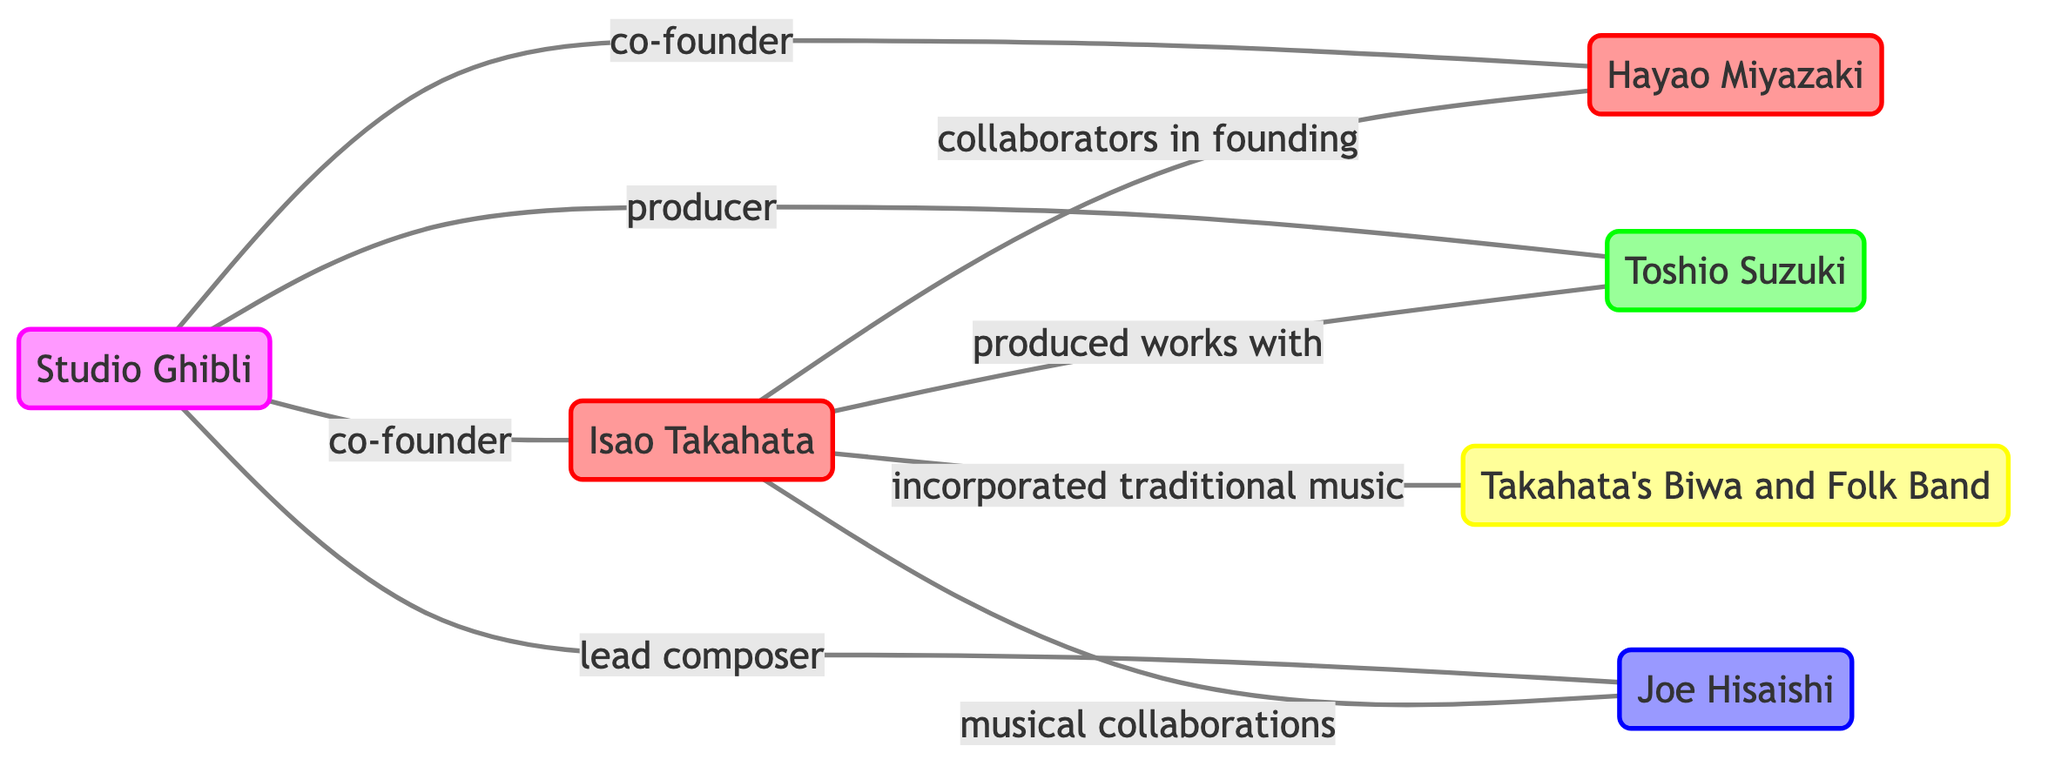What is the total number of nodes in the diagram? The diagram shows six distinct nodes: Isao Takahata, Hayao Miyazaki, Toshio Suzuki, Joe Hisaishi, Takahata's Biwa and Folk Band, and Studio Ghibli. Therefore, the total number is six.
Answer: 6 Who collaborated with Isao Takahata in founding Studio Ghibli? The diagram indicates that Hayao Miyazaki is specifically noted as a collaborator with Isao Takahata in founding Studio Ghibli.
Answer: Hayao Miyazaki What type of role does Toshio Suzuki fulfill in relation to Isao Takahata? Referring to the diagram, Isao Takahata has a relationship labeled 'produced works with' linking him to Toshio Suzuki. This indicates Suzuki's role as a producer for Takahata's works.
Answer: producer How many musical collaborations are indicated for Isao Takahata? The diagram shows that Isao Takahata has a direct link labeled 'musical collaborations' to Joe Hisaishi and another link to 'Takahata's Biwa and Folk Band' indicating two musical collaborations.
Answer: 2 Which studio is co-founded by Isao Takahata? According to the diagram, Studio Ghibli is linked to Isao Takahata with a relationship labeled 'co-founder', showing that Takahata played a significant role in its establishment.
Answer: Studio Ghibli What is the relationship between Studio Ghibli and Joe Hisaishi? The diagram illustrates a relationship labeled 'lead composer' between Studio Ghibli and Joe Hisaishi, indicating his key role in the studio’s productions.
Answer: lead composer Who is associated with incorporating traditional music in Isao Takahata's works? The diagram highlights a direct link from Isao Takahata to 'Takahata's Biwa and Folk Band' with the relationship 'incorporated traditional music', showing their association in his works.
Answer: Takahata's Biwa and Folk Band What color represents composers in this diagram? In the diagram's legend, composers are represented by a color fill of dark blue (#9999ff) with outlines reflecting blue hues, indicating the specific color used for this group.
Answer: #9999ff How many producers are depicted in the diagram? The diagram shows one producer, Toshio Suzuki, who has links with Isao Takahata and Studio Ghibli under a producer role, confirming the total count as one.
Answer: 1 